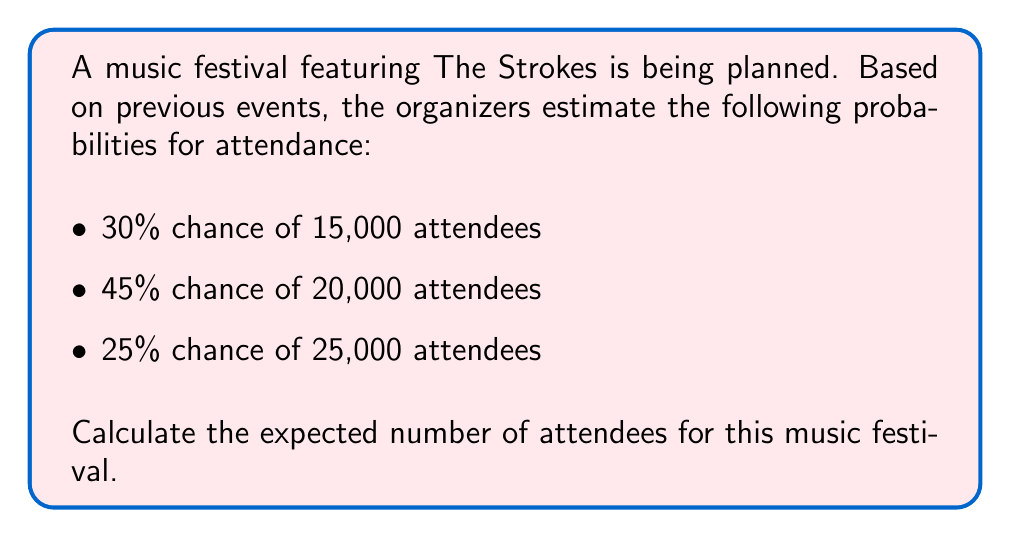What is the answer to this math problem? To calculate the expected number of attendees, we need to use the concept of expected value. The expected value is the sum of each possible outcome multiplied by its probability.

Let's break it down step-by-step:

1. Identify the possible outcomes and their probabilities:
   - 15,000 attendees with 30% probability (0.30)
   - 20,000 attendees with 45% probability (0.45)
   - 25,000 attendees with 25% probability (0.25)

2. Calculate the expected value using the formula:
   
   $$E(X) = \sum_{i=1}^{n} x_i \cdot p(x_i)$$

   Where $x_i$ is each possible outcome and $p(x_i)$ is its probability.

3. Plug in the values:

   $$E(X) = (15,000 \cdot 0.30) + (20,000 \cdot 0.45) + (25,000 \cdot 0.25)$$

4. Solve:
   
   $$E(X) = 4,500 + 9,000 + 6,250 = 19,750$$

Therefore, the expected number of attendees at the music festival featuring The Strokes is 19,750.
Answer: 19,750 attendees 